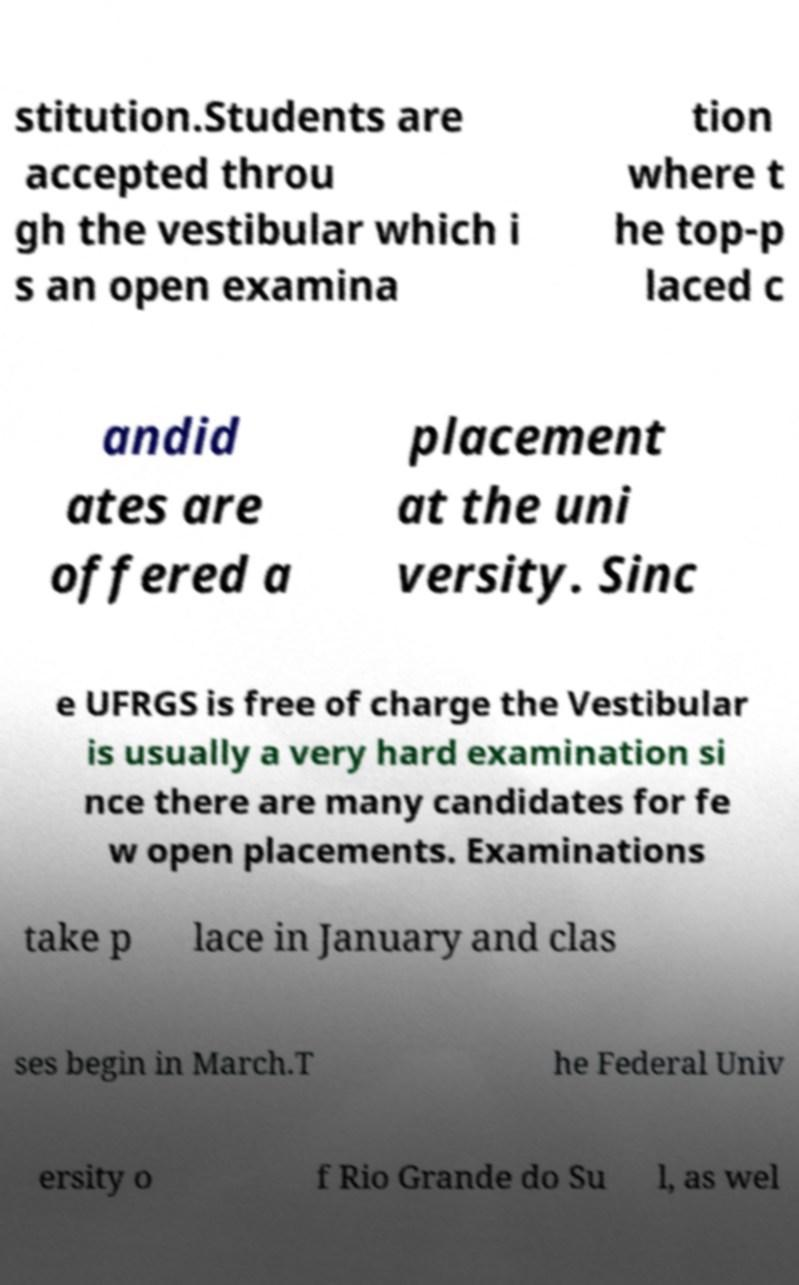Can you read and provide the text displayed in the image?This photo seems to have some interesting text. Can you extract and type it out for me? stitution.Students are accepted throu gh the vestibular which i s an open examina tion where t he top-p laced c andid ates are offered a placement at the uni versity. Sinc e UFRGS is free of charge the Vestibular is usually a very hard examination si nce there are many candidates for fe w open placements. Examinations take p lace in January and clas ses begin in March.T he Federal Univ ersity o f Rio Grande do Su l, as wel 